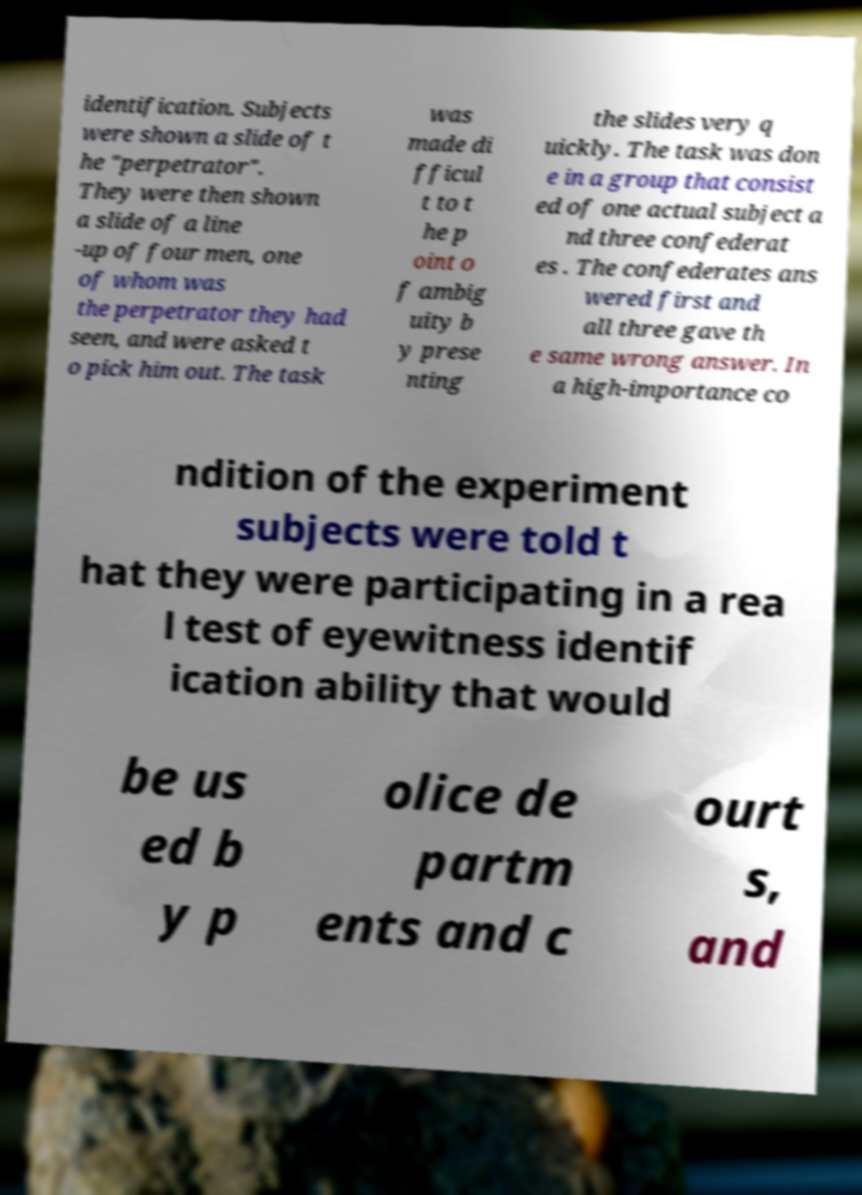I need the written content from this picture converted into text. Can you do that? identification. Subjects were shown a slide of t he "perpetrator". They were then shown a slide of a line -up of four men, one of whom was the perpetrator they had seen, and were asked t o pick him out. The task was made di fficul t to t he p oint o f ambig uity b y prese nting the slides very q uickly. The task was don e in a group that consist ed of one actual subject a nd three confederat es . The confederates ans wered first and all three gave th e same wrong answer. In a high-importance co ndition of the experiment subjects were told t hat they were participating in a rea l test of eyewitness identif ication ability that would be us ed b y p olice de partm ents and c ourt s, and 